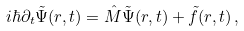Convert formula to latex. <formula><loc_0><loc_0><loc_500><loc_500>i \hbar { \partial } _ { t } { \tilde { \Psi } } ( { r } , t ) = \hat { M } { \tilde { \Psi } } ( { r } , t ) + { \tilde { f } } ( { r } , t ) \, ,</formula> 